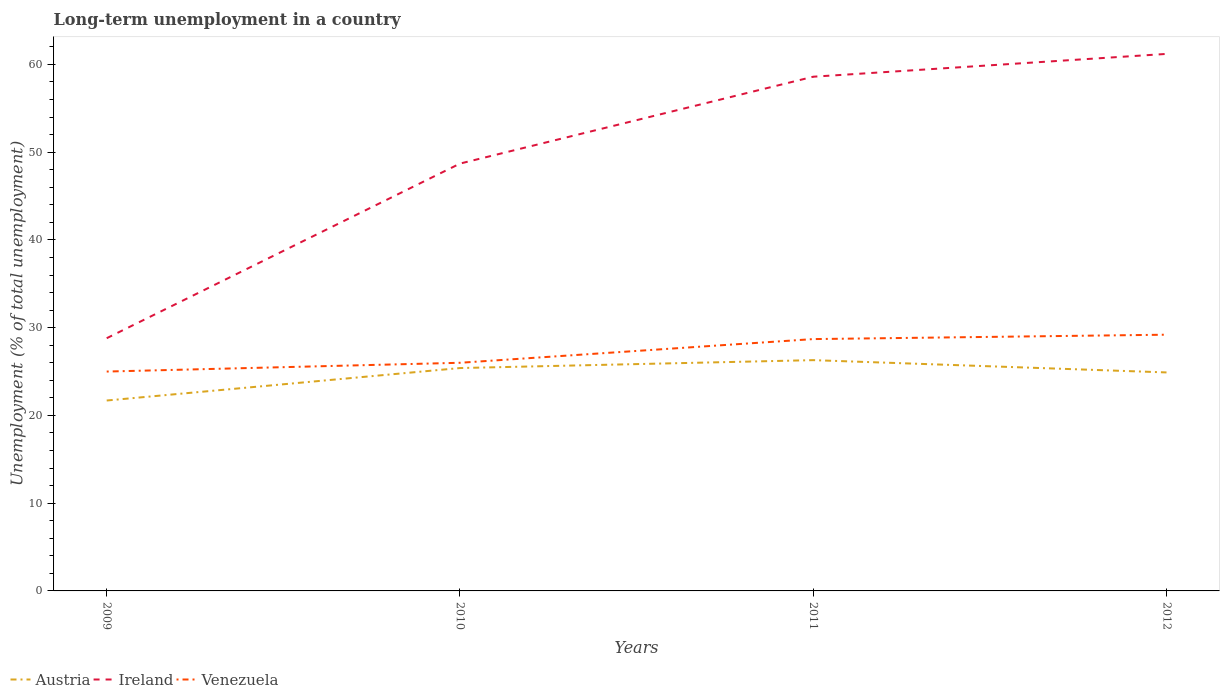How many different coloured lines are there?
Your response must be concise. 3. Does the line corresponding to Venezuela intersect with the line corresponding to Ireland?
Keep it short and to the point. No. Is the number of lines equal to the number of legend labels?
Offer a terse response. Yes. Across all years, what is the maximum percentage of long-term unemployed population in Austria?
Your answer should be very brief. 21.7. In which year was the percentage of long-term unemployed population in Austria maximum?
Keep it short and to the point. 2009. What is the total percentage of long-term unemployed population in Venezuela in the graph?
Make the answer very short. -2.7. What is the difference between the highest and the second highest percentage of long-term unemployed population in Austria?
Offer a terse response. 4.6. What is the difference between the highest and the lowest percentage of long-term unemployed population in Venezuela?
Keep it short and to the point. 2. Are the values on the major ticks of Y-axis written in scientific E-notation?
Ensure brevity in your answer.  No. How many legend labels are there?
Offer a terse response. 3. What is the title of the graph?
Ensure brevity in your answer.  Long-term unemployment in a country. Does "Solomon Islands" appear as one of the legend labels in the graph?
Your answer should be compact. No. What is the label or title of the X-axis?
Provide a succinct answer. Years. What is the label or title of the Y-axis?
Offer a terse response. Unemployment (% of total unemployment). What is the Unemployment (% of total unemployment) in Austria in 2009?
Give a very brief answer. 21.7. What is the Unemployment (% of total unemployment) of Ireland in 2009?
Provide a succinct answer. 28.8. What is the Unemployment (% of total unemployment) of Austria in 2010?
Offer a very short reply. 25.4. What is the Unemployment (% of total unemployment) in Ireland in 2010?
Offer a very short reply. 48.7. What is the Unemployment (% of total unemployment) in Venezuela in 2010?
Your answer should be compact. 26. What is the Unemployment (% of total unemployment) of Austria in 2011?
Make the answer very short. 26.3. What is the Unemployment (% of total unemployment) of Ireland in 2011?
Your answer should be compact. 58.6. What is the Unemployment (% of total unemployment) in Venezuela in 2011?
Offer a terse response. 28.7. What is the Unemployment (% of total unemployment) of Austria in 2012?
Make the answer very short. 24.9. What is the Unemployment (% of total unemployment) of Ireland in 2012?
Your response must be concise. 61.2. What is the Unemployment (% of total unemployment) of Venezuela in 2012?
Make the answer very short. 29.2. Across all years, what is the maximum Unemployment (% of total unemployment) in Austria?
Make the answer very short. 26.3. Across all years, what is the maximum Unemployment (% of total unemployment) of Ireland?
Offer a terse response. 61.2. Across all years, what is the maximum Unemployment (% of total unemployment) in Venezuela?
Give a very brief answer. 29.2. Across all years, what is the minimum Unemployment (% of total unemployment) in Austria?
Offer a very short reply. 21.7. Across all years, what is the minimum Unemployment (% of total unemployment) in Ireland?
Your answer should be compact. 28.8. What is the total Unemployment (% of total unemployment) in Austria in the graph?
Give a very brief answer. 98.3. What is the total Unemployment (% of total unemployment) in Ireland in the graph?
Keep it short and to the point. 197.3. What is the total Unemployment (% of total unemployment) in Venezuela in the graph?
Offer a terse response. 108.9. What is the difference between the Unemployment (% of total unemployment) of Ireland in 2009 and that in 2010?
Offer a terse response. -19.9. What is the difference between the Unemployment (% of total unemployment) of Venezuela in 2009 and that in 2010?
Give a very brief answer. -1. What is the difference between the Unemployment (% of total unemployment) in Austria in 2009 and that in 2011?
Offer a terse response. -4.6. What is the difference between the Unemployment (% of total unemployment) of Ireland in 2009 and that in 2011?
Offer a very short reply. -29.8. What is the difference between the Unemployment (% of total unemployment) in Venezuela in 2009 and that in 2011?
Make the answer very short. -3.7. What is the difference between the Unemployment (% of total unemployment) of Ireland in 2009 and that in 2012?
Offer a very short reply. -32.4. What is the difference between the Unemployment (% of total unemployment) in Venezuela in 2009 and that in 2012?
Ensure brevity in your answer.  -4.2. What is the difference between the Unemployment (% of total unemployment) of Austria in 2010 and that in 2012?
Make the answer very short. 0.5. What is the difference between the Unemployment (% of total unemployment) of Austria in 2011 and that in 2012?
Ensure brevity in your answer.  1.4. What is the difference between the Unemployment (% of total unemployment) in Austria in 2009 and the Unemployment (% of total unemployment) in Ireland in 2011?
Make the answer very short. -36.9. What is the difference between the Unemployment (% of total unemployment) in Austria in 2009 and the Unemployment (% of total unemployment) in Ireland in 2012?
Provide a short and direct response. -39.5. What is the difference between the Unemployment (% of total unemployment) in Ireland in 2009 and the Unemployment (% of total unemployment) in Venezuela in 2012?
Your answer should be compact. -0.4. What is the difference between the Unemployment (% of total unemployment) in Austria in 2010 and the Unemployment (% of total unemployment) in Ireland in 2011?
Make the answer very short. -33.2. What is the difference between the Unemployment (% of total unemployment) in Austria in 2010 and the Unemployment (% of total unemployment) in Venezuela in 2011?
Your response must be concise. -3.3. What is the difference between the Unemployment (% of total unemployment) of Ireland in 2010 and the Unemployment (% of total unemployment) of Venezuela in 2011?
Give a very brief answer. 20. What is the difference between the Unemployment (% of total unemployment) of Austria in 2010 and the Unemployment (% of total unemployment) of Ireland in 2012?
Ensure brevity in your answer.  -35.8. What is the difference between the Unemployment (% of total unemployment) of Austria in 2011 and the Unemployment (% of total unemployment) of Ireland in 2012?
Your answer should be very brief. -34.9. What is the difference between the Unemployment (% of total unemployment) in Austria in 2011 and the Unemployment (% of total unemployment) in Venezuela in 2012?
Provide a short and direct response. -2.9. What is the difference between the Unemployment (% of total unemployment) of Ireland in 2011 and the Unemployment (% of total unemployment) of Venezuela in 2012?
Your answer should be very brief. 29.4. What is the average Unemployment (% of total unemployment) of Austria per year?
Your response must be concise. 24.57. What is the average Unemployment (% of total unemployment) of Ireland per year?
Provide a succinct answer. 49.33. What is the average Unemployment (% of total unemployment) of Venezuela per year?
Offer a very short reply. 27.23. In the year 2009, what is the difference between the Unemployment (% of total unemployment) of Austria and Unemployment (% of total unemployment) of Ireland?
Give a very brief answer. -7.1. In the year 2009, what is the difference between the Unemployment (% of total unemployment) in Austria and Unemployment (% of total unemployment) in Venezuela?
Provide a short and direct response. -3.3. In the year 2010, what is the difference between the Unemployment (% of total unemployment) of Austria and Unemployment (% of total unemployment) of Ireland?
Offer a terse response. -23.3. In the year 2010, what is the difference between the Unemployment (% of total unemployment) in Ireland and Unemployment (% of total unemployment) in Venezuela?
Provide a succinct answer. 22.7. In the year 2011, what is the difference between the Unemployment (% of total unemployment) of Austria and Unemployment (% of total unemployment) of Ireland?
Give a very brief answer. -32.3. In the year 2011, what is the difference between the Unemployment (% of total unemployment) of Ireland and Unemployment (% of total unemployment) of Venezuela?
Give a very brief answer. 29.9. In the year 2012, what is the difference between the Unemployment (% of total unemployment) of Austria and Unemployment (% of total unemployment) of Ireland?
Offer a terse response. -36.3. In the year 2012, what is the difference between the Unemployment (% of total unemployment) in Austria and Unemployment (% of total unemployment) in Venezuela?
Your response must be concise. -4.3. In the year 2012, what is the difference between the Unemployment (% of total unemployment) in Ireland and Unemployment (% of total unemployment) in Venezuela?
Ensure brevity in your answer.  32. What is the ratio of the Unemployment (% of total unemployment) of Austria in 2009 to that in 2010?
Offer a very short reply. 0.85. What is the ratio of the Unemployment (% of total unemployment) of Ireland in 2009 to that in 2010?
Make the answer very short. 0.59. What is the ratio of the Unemployment (% of total unemployment) in Venezuela in 2009 to that in 2010?
Make the answer very short. 0.96. What is the ratio of the Unemployment (% of total unemployment) in Austria in 2009 to that in 2011?
Your answer should be compact. 0.83. What is the ratio of the Unemployment (% of total unemployment) of Ireland in 2009 to that in 2011?
Provide a short and direct response. 0.49. What is the ratio of the Unemployment (% of total unemployment) of Venezuela in 2009 to that in 2011?
Offer a terse response. 0.87. What is the ratio of the Unemployment (% of total unemployment) of Austria in 2009 to that in 2012?
Your response must be concise. 0.87. What is the ratio of the Unemployment (% of total unemployment) of Ireland in 2009 to that in 2012?
Keep it short and to the point. 0.47. What is the ratio of the Unemployment (% of total unemployment) of Venezuela in 2009 to that in 2012?
Your answer should be compact. 0.86. What is the ratio of the Unemployment (% of total unemployment) of Austria in 2010 to that in 2011?
Ensure brevity in your answer.  0.97. What is the ratio of the Unemployment (% of total unemployment) in Ireland in 2010 to that in 2011?
Ensure brevity in your answer.  0.83. What is the ratio of the Unemployment (% of total unemployment) of Venezuela in 2010 to that in 2011?
Offer a very short reply. 0.91. What is the ratio of the Unemployment (% of total unemployment) in Austria in 2010 to that in 2012?
Provide a short and direct response. 1.02. What is the ratio of the Unemployment (% of total unemployment) of Ireland in 2010 to that in 2012?
Ensure brevity in your answer.  0.8. What is the ratio of the Unemployment (% of total unemployment) of Venezuela in 2010 to that in 2012?
Your response must be concise. 0.89. What is the ratio of the Unemployment (% of total unemployment) of Austria in 2011 to that in 2012?
Provide a short and direct response. 1.06. What is the ratio of the Unemployment (% of total unemployment) of Ireland in 2011 to that in 2012?
Offer a terse response. 0.96. What is the ratio of the Unemployment (% of total unemployment) of Venezuela in 2011 to that in 2012?
Ensure brevity in your answer.  0.98. What is the difference between the highest and the second highest Unemployment (% of total unemployment) in Venezuela?
Give a very brief answer. 0.5. What is the difference between the highest and the lowest Unemployment (% of total unemployment) of Ireland?
Ensure brevity in your answer.  32.4. 